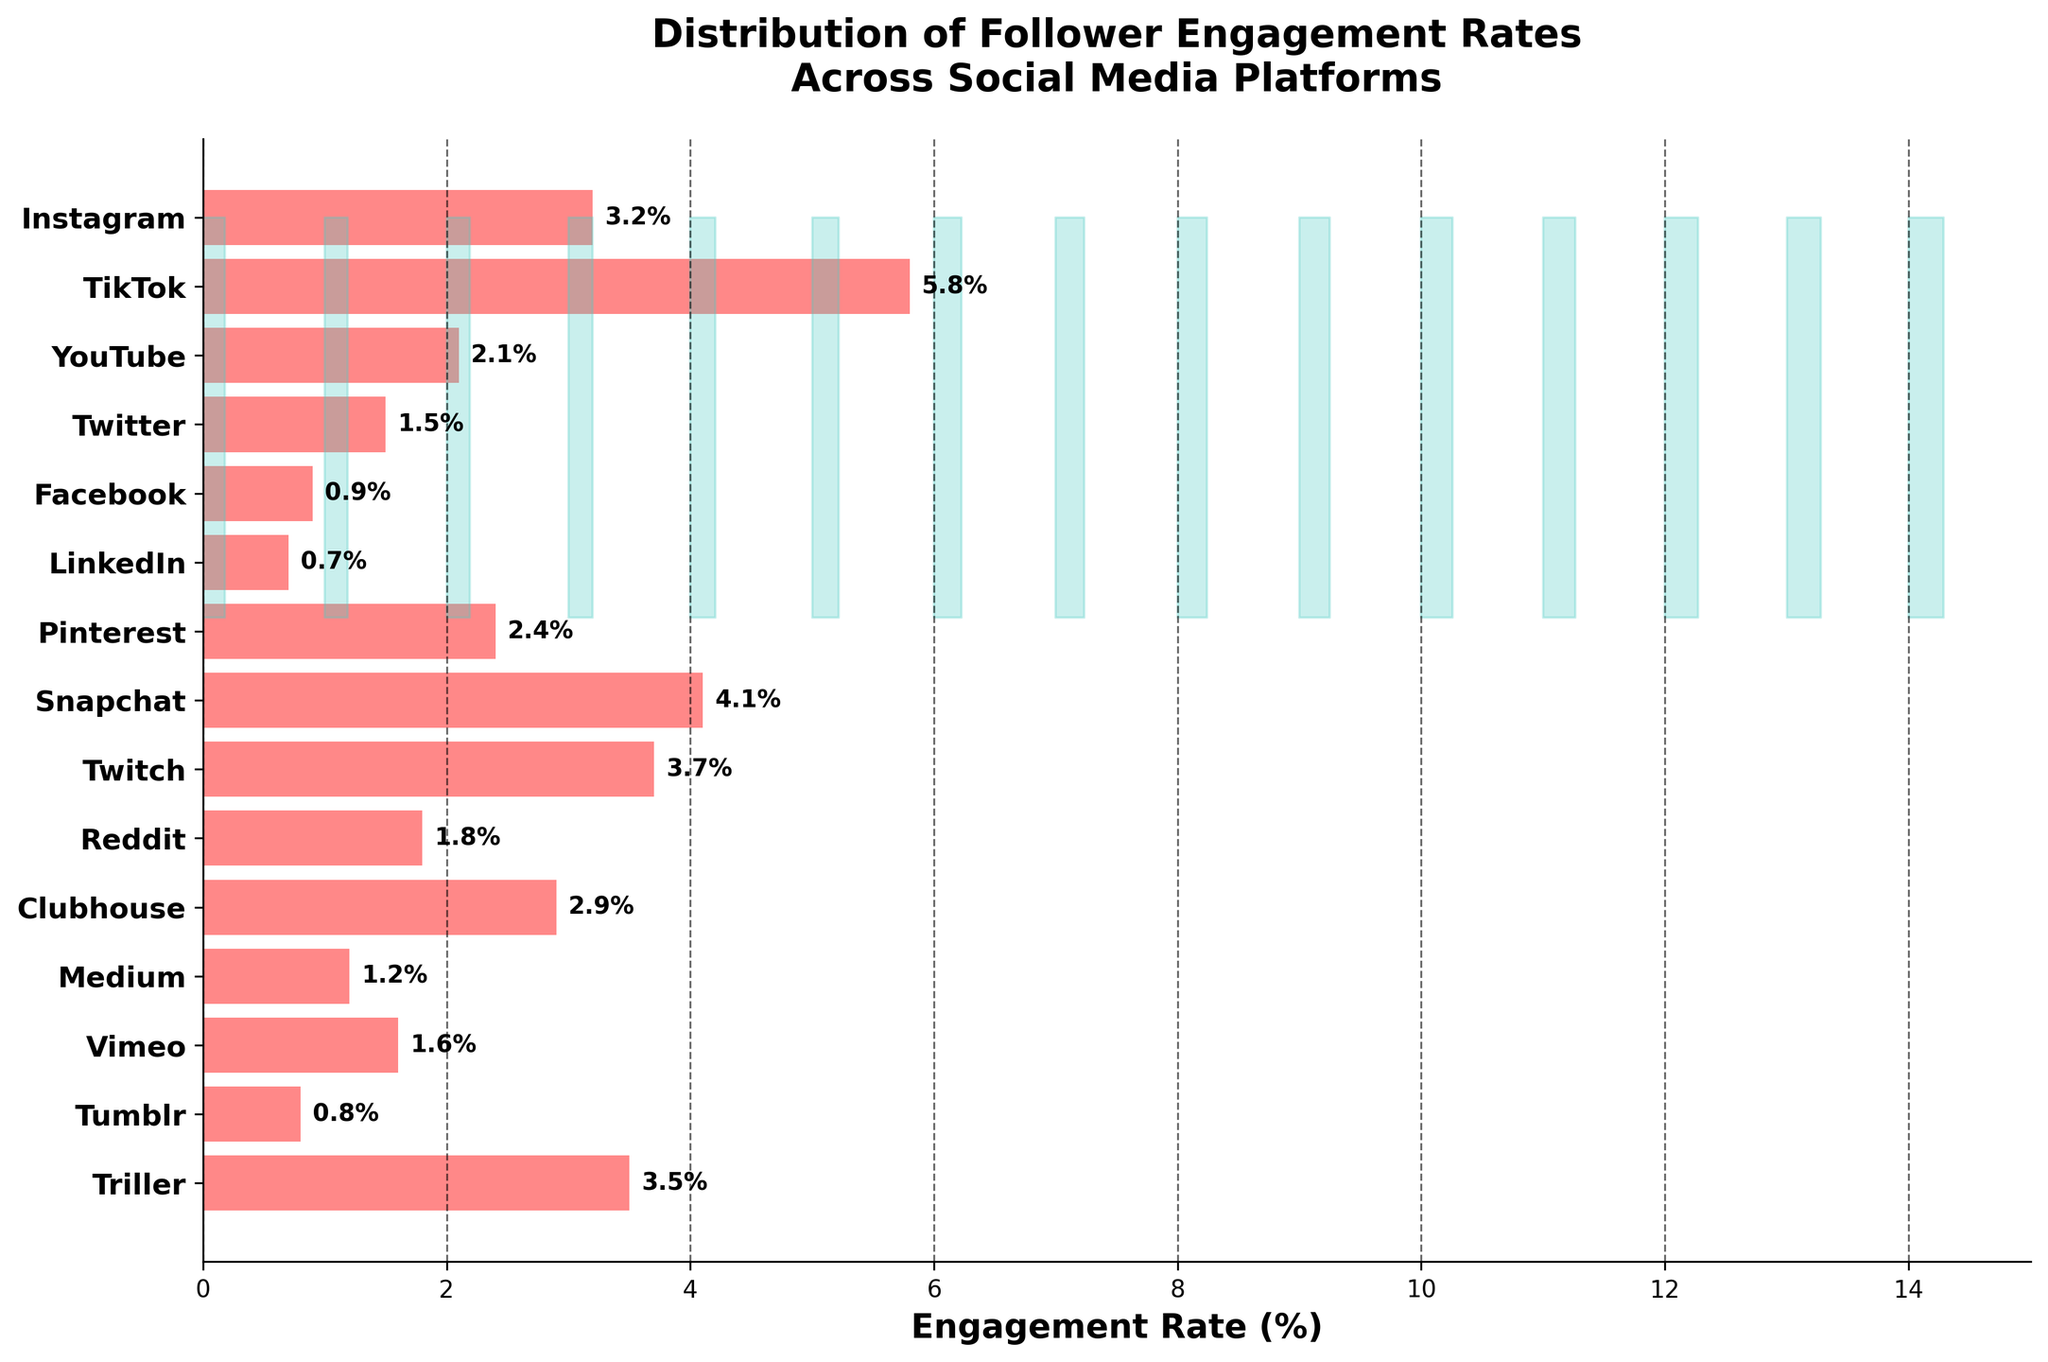What is the title of the plot? The title is found at the top of the figure, typically describing the main theme or findings presented in the chart.
Answer: Distribution of Follower Engagement Rates Across Social Media Platforms Which platform has the highest engagement rate? To find the highest engagement rate, look for the longest horizontal bar in the plot.
Answer: TikTok How is the engagement rate represented visually? The engagement rate is represented by the length of horizontal bars; longer bars indicate higher engagement rates.
Answer: Length of horizontal bars What is the engagement rate for Instagram? Locate the bar labeled 'Instagram' and read the corresponding engagement rate value from the axis.
Answer: 3.2% Which platform has the lowest engagement rate? Find the shortest horizontal bar in the plot, which indicates the lowest engagement rate.
Answer: LinkedIn What is the average engagement rate across all platforms? Sum up all the engagement rates and divide by the total number of platforms: (3.2 + 5.8 + 2.1 + 1.5 + 0.9 + 0.7 + 2.4 + 4.1 + 3.7 + 1.8 + 2.9 + 1.2 + 1.6 + 0.8 + 3.5) / 15.
Answer: 2.55% Compare the engagement rates of YouTube and Snapchat. Which is higher? Look at the lengths of the horizontal bars for YouTube and Snapchat and compare them.
Answer: Snapchat is higher What's the median engagement rate? List all engagement rates in ascending order and find the middle value, considering there are 15 platforms: 0.7, 0.8, 0.9, 1.2, 1.5, 1.6, 1.8, 2.1, 2.4, 2.9, 3.2, 3.5, 3.7, 4.1, 5.8. The 8th value is the median.
Answer: 2.1% Which platform has an engagement rate closest to 3%? Look at the engagement rates and identify which one is closest to 3%.
Answer: Clubhouse How does the density estimation contribute to the plot's interpretation? The density estimation (shaded areas) visually shows the frequency distribution of engagement rates across different platforms, enhancing our understanding of data concentration.
Answer: Shows frequency distribution 